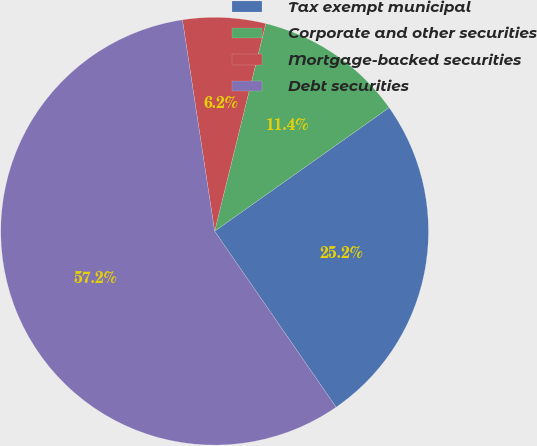<chart> <loc_0><loc_0><loc_500><loc_500><pie_chart><fcel>Tax exempt municipal<fcel>Corporate and other securities<fcel>Mortgage-backed securities<fcel>Debt securities<nl><fcel>25.19%<fcel>11.35%<fcel>6.25%<fcel>57.21%<nl></chart> 